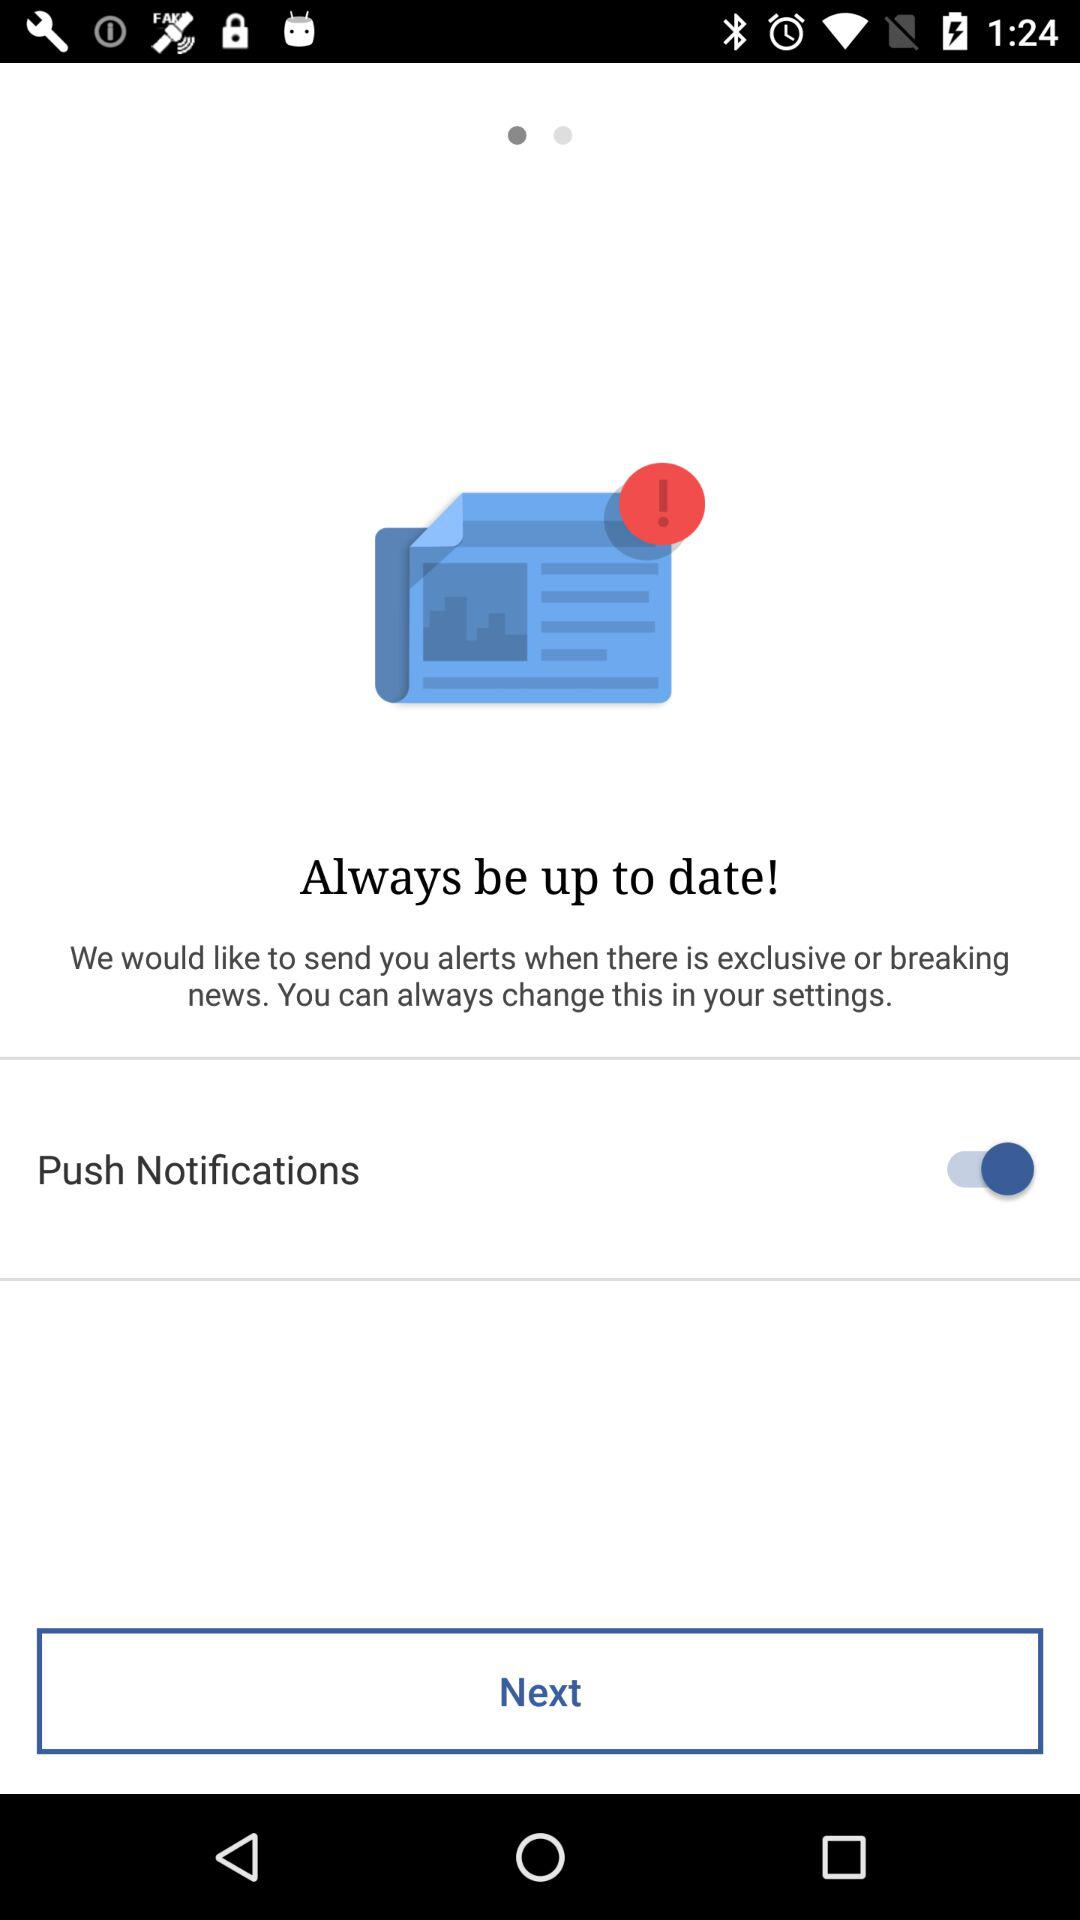What is the status of the "Push Notifications" setting? The status of the "Push Notifications" setting is "on". 